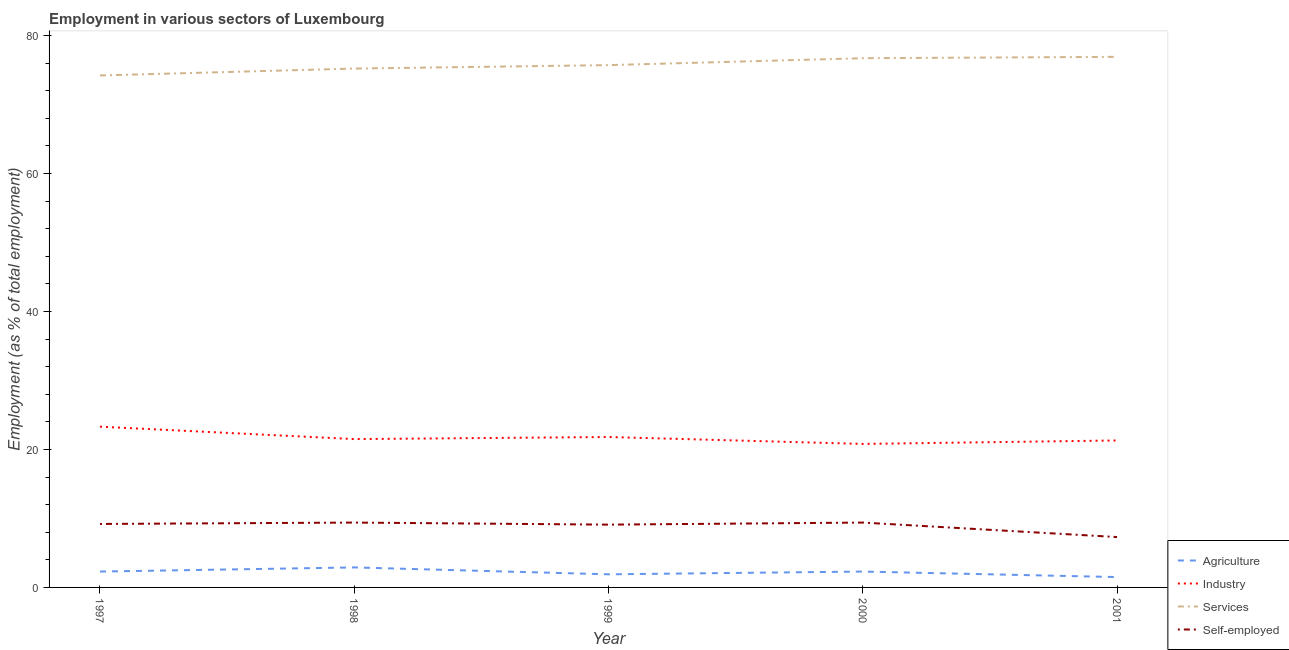What is the percentage of workers in agriculture in 1997?
Offer a terse response. 2.3. Across all years, what is the maximum percentage of workers in services?
Offer a very short reply. 76.9. Across all years, what is the minimum percentage of self employed workers?
Provide a short and direct response. 7.3. In which year was the percentage of workers in industry minimum?
Your answer should be compact. 2000. What is the total percentage of workers in industry in the graph?
Your answer should be compact. 108.7. What is the difference between the percentage of workers in agriculture in 1997 and that in 1998?
Offer a very short reply. -0.6. What is the difference between the percentage of self employed workers in 1997 and the percentage of workers in agriculture in 2000?
Make the answer very short. 6.9. What is the average percentage of workers in industry per year?
Make the answer very short. 21.74. In the year 1999, what is the difference between the percentage of workers in services and percentage of self employed workers?
Offer a very short reply. 66.6. In how many years, is the percentage of workers in industry greater than 56 %?
Provide a short and direct response. 0. What is the ratio of the percentage of workers in services in 1997 to that in 2000?
Your answer should be compact. 0.97. Is the percentage of workers in agriculture in 1999 less than that in 2000?
Give a very brief answer. Yes. What is the difference between the highest and the second highest percentage of workers in services?
Provide a succinct answer. 0.2. What is the difference between the highest and the lowest percentage of workers in services?
Offer a very short reply. 2.7. Is the percentage of workers in services strictly greater than the percentage of workers in industry over the years?
Offer a terse response. Yes. How many years are there in the graph?
Offer a very short reply. 5. What is the difference between two consecutive major ticks on the Y-axis?
Your response must be concise. 20. How are the legend labels stacked?
Keep it short and to the point. Vertical. What is the title of the graph?
Offer a very short reply. Employment in various sectors of Luxembourg. What is the label or title of the X-axis?
Make the answer very short. Year. What is the label or title of the Y-axis?
Offer a terse response. Employment (as % of total employment). What is the Employment (as % of total employment) in Agriculture in 1997?
Make the answer very short. 2.3. What is the Employment (as % of total employment) of Industry in 1997?
Your response must be concise. 23.3. What is the Employment (as % of total employment) in Services in 1997?
Offer a terse response. 74.2. What is the Employment (as % of total employment) of Self-employed in 1997?
Your response must be concise. 9.2. What is the Employment (as % of total employment) in Agriculture in 1998?
Ensure brevity in your answer.  2.9. What is the Employment (as % of total employment) in Services in 1998?
Give a very brief answer. 75.2. What is the Employment (as % of total employment) in Self-employed in 1998?
Your answer should be very brief. 9.4. What is the Employment (as % of total employment) in Agriculture in 1999?
Ensure brevity in your answer.  1.9. What is the Employment (as % of total employment) in Industry in 1999?
Offer a terse response. 21.8. What is the Employment (as % of total employment) of Services in 1999?
Provide a short and direct response. 75.7. What is the Employment (as % of total employment) of Self-employed in 1999?
Provide a succinct answer. 9.1. What is the Employment (as % of total employment) in Agriculture in 2000?
Your answer should be very brief. 2.3. What is the Employment (as % of total employment) in Industry in 2000?
Provide a succinct answer. 20.8. What is the Employment (as % of total employment) of Services in 2000?
Provide a succinct answer. 76.7. What is the Employment (as % of total employment) of Self-employed in 2000?
Ensure brevity in your answer.  9.4. What is the Employment (as % of total employment) of Industry in 2001?
Offer a very short reply. 21.3. What is the Employment (as % of total employment) in Services in 2001?
Offer a terse response. 76.9. What is the Employment (as % of total employment) of Self-employed in 2001?
Give a very brief answer. 7.3. Across all years, what is the maximum Employment (as % of total employment) in Agriculture?
Ensure brevity in your answer.  2.9. Across all years, what is the maximum Employment (as % of total employment) of Industry?
Provide a succinct answer. 23.3. Across all years, what is the maximum Employment (as % of total employment) in Services?
Provide a short and direct response. 76.9. Across all years, what is the maximum Employment (as % of total employment) of Self-employed?
Keep it short and to the point. 9.4. Across all years, what is the minimum Employment (as % of total employment) in Agriculture?
Offer a very short reply. 1.5. Across all years, what is the minimum Employment (as % of total employment) of Industry?
Your response must be concise. 20.8. Across all years, what is the minimum Employment (as % of total employment) in Services?
Your answer should be very brief. 74.2. Across all years, what is the minimum Employment (as % of total employment) in Self-employed?
Give a very brief answer. 7.3. What is the total Employment (as % of total employment) in Industry in the graph?
Your response must be concise. 108.7. What is the total Employment (as % of total employment) in Services in the graph?
Provide a succinct answer. 378.7. What is the total Employment (as % of total employment) in Self-employed in the graph?
Make the answer very short. 44.4. What is the difference between the Employment (as % of total employment) in Agriculture in 1997 and that in 1998?
Ensure brevity in your answer.  -0.6. What is the difference between the Employment (as % of total employment) of Industry in 1997 and that in 1998?
Your answer should be compact. 1.8. What is the difference between the Employment (as % of total employment) in Services in 1997 and that in 1998?
Offer a terse response. -1. What is the difference between the Employment (as % of total employment) of Industry in 1997 and that in 1999?
Your answer should be compact. 1.5. What is the difference between the Employment (as % of total employment) of Services in 1997 and that in 1999?
Offer a very short reply. -1.5. What is the difference between the Employment (as % of total employment) in Self-employed in 1997 and that in 1999?
Give a very brief answer. 0.1. What is the difference between the Employment (as % of total employment) of Services in 1997 and that in 2000?
Your answer should be very brief. -2.5. What is the difference between the Employment (as % of total employment) of Agriculture in 1997 and that in 2001?
Ensure brevity in your answer.  0.8. What is the difference between the Employment (as % of total employment) in Industry in 1997 and that in 2001?
Offer a terse response. 2. What is the difference between the Employment (as % of total employment) in Self-employed in 1997 and that in 2001?
Your answer should be compact. 1.9. What is the difference between the Employment (as % of total employment) in Services in 1998 and that in 1999?
Make the answer very short. -0.5. What is the difference between the Employment (as % of total employment) in Self-employed in 1998 and that in 1999?
Ensure brevity in your answer.  0.3. What is the difference between the Employment (as % of total employment) in Agriculture in 1998 and that in 2000?
Your answer should be very brief. 0.6. What is the difference between the Employment (as % of total employment) in Industry in 1998 and that in 2000?
Provide a short and direct response. 0.7. What is the difference between the Employment (as % of total employment) in Services in 1998 and that in 2000?
Offer a very short reply. -1.5. What is the difference between the Employment (as % of total employment) in Self-employed in 1998 and that in 2000?
Provide a short and direct response. 0. What is the difference between the Employment (as % of total employment) of Self-employed in 1998 and that in 2001?
Ensure brevity in your answer.  2.1. What is the difference between the Employment (as % of total employment) of Agriculture in 1999 and that in 2000?
Provide a succinct answer. -0.4. What is the difference between the Employment (as % of total employment) of Industry in 1999 and that in 2000?
Your answer should be compact. 1. What is the difference between the Employment (as % of total employment) of Services in 1999 and that in 2000?
Provide a succinct answer. -1. What is the difference between the Employment (as % of total employment) in Self-employed in 1999 and that in 2000?
Ensure brevity in your answer.  -0.3. What is the difference between the Employment (as % of total employment) of Industry in 1999 and that in 2001?
Offer a very short reply. 0.5. What is the difference between the Employment (as % of total employment) of Agriculture in 2000 and that in 2001?
Make the answer very short. 0.8. What is the difference between the Employment (as % of total employment) of Industry in 2000 and that in 2001?
Give a very brief answer. -0.5. What is the difference between the Employment (as % of total employment) in Self-employed in 2000 and that in 2001?
Keep it short and to the point. 2.1. What is the difference between the Employment (as % of total employment) of Agriculture in 1997 and the Employment (as % of total employment) of Industry in 1998?
Provide a short and direct response. -19.2. What is the difference between the Employment (as % of total employment) of Agriculture in 1997 and the Employment (as % of total employment) of Services in 1998?
Offer a terse response. -72.9. What is the difference between the Employment (as % of total employment) of Agriculture in 1997 and the Employment (as % of total employment) of Self-employed in 1998?
Provide a succinct answer. -7.1. What is the difference between the Employment (as % of total employment) of Industry in 1997 and the Employment (as % of total employment) of Services in 1998?
Keep it short and to the point. -51.9. What is the difference between the Employment (as % of total employment) in Services in 1997 and the Employment (as % of total employment) in Self-employed in 1998?
Offer a very short reply. 64.8. What is the difference between the Employment (as % of total employment) in Agriculture in 1997 and the Employment (as % of total employment) in Industry in 1999?
Provide a short and direct response. -19.5. What is the difference between the Employment (as % of total employment) of Agriculture in 1997 and the Employment (as % of total employment) of Services in 1999?
Your answer should be compact. -73.4. What is the difference between the Employment (as % of total employment) in Agriculture in 1997 and the Employment (as % of total employment) in Self-employed in 1999?
Your response must be concise. -6.8. What is the difference between the Employment (as % of total employment) in Industry in 1997 and the Employment (as % of total employment) in Services in 1999?
Offer a terse response. -52.4. What is the difference between the Employment (as % of total employment) in Industry in 1997 and the Employment (as % of total employment) in Self-employed in 1999?
Give a very brief answer. 14.2. What is the difference between the Employment (as % of total employment) in Services in 1997 and the Employment (as % of total employment) in Self-employed in 1999?
Your answer should be very brief. 65.1. What is the difference between the Employment (as % of total employment) of Agriculture in 1997 and the Employment (as % of total employment) of Industry in 2000?
Offer a very short reply. -18.5. What is the difference between the Employment (as % of total employment) of Agriculture in 1997 and the Employment (as % of total employment) of Services in 2000?
Give a very brief answer. -74.4. What is the difference between the Employment (as % of total employment) of Agriculture in 1997 and the Employment (as % of total employment) of Self-employed in 2000?
Give a very brief answer. -7.1. What is the difference between the Employment (as % of total employment) in Industry in 1997 and the Employment (as % of total employment) in Services in 2000?
Offer a very short reply. -53.4. What is the difference between the Employment (as % of total employment) of Services in 1997 and the Employment (as % of total employment) of Self-employed in 2000?
Your answer should be very brief. 64.8. What is the difference between the Employment (as % of total employment) in Agriculture in 1997 and the Employment (as % of total employment) in Industry in 2001?
Keep it short and to the point. -19. What is the difference between the Employment (as % of total employment) of Agriculture in 1997 and the Employment (as % of total employment) of Services in 2001?
Offer a terse response. -74.6. What is the difference between the Employment (as % of total employment) in Industry in 1997 and the Employment (as % of total employment) in Services in 2001?
Offer a terse response. -53.6. What is the difference between the Employment (as % of total employment) of Industry in 1997 and the Employment (as % of total employment) of Self-employed in 2001?
Provide a short and direct response. 16. What is the difference between the Employment (as % of total employment) of Services in 1997 and the Employment (as % of total employment) of Self-employed in 2001?
Keep it short and to the point. 66.9. What is the difference between the Employment (as % of total employment) in Agriculture in 1998 and the Employment (as % of total employment) in Industry in 1999?
Make the answer very short. -18.9. What is the difference between the Employment (as % of total employment) of Agriculture in 1998 and the Employment (as % of total employment) of Services in 1999?
Your response must be concise. -72.8. What is the difference between the Employment (as % of total employment) in Agriculture in 1998 and the Employment (as % of total employment) in Self-employed in 1999?
Offer a terse response. -6.2. What is the difference between the Employment (as % of total employment) in Industry in 1998 and the Employment (as % of total employment) in Services in 1999?
Keep it short and to the point. -54.2. What is the difference between the Employment (as % of total employment) in Industry in 1998 and the Employment (as % of total employment) in Self-employed in 1999?
Ensure brevity in your answer.  12.4. What is the difference between the Employment (as % of total employment) in Services in 1998 and the Employment (as % of total employment) in Self-employed in 1999?
Provide a short and direct response. 66.1. What is the difference between the Employment (as % of total employment) in Agriculture in 1998 and the Employment (as % of total employment) in Industry in 2000?
Provide a succinct answer. -17.9. What is the difference between the Employment (as % of total employment) in Agriculture in 1998 and the Employment (as % of total employment) in Services in 2000?
Give a very brief answer. -73.8. What is the difference between the Employment (as % of total employment) in Industry in 1998 and the Employment (as % of total employment) in Services in 2000?
Your answer should be very brief. -55.2. What is the difference between the Employment (as % of total employment) of Industry in 1998 and the Employment (as % of total employment) of Self-employed in 2000?
Offer a terse response. 12.1. What is the difference between the Employment (as % of total employment) of Services in 1998 and the Employment (as % of total employment) of Self-employed in 2000?
Your answer should be compact. 65.8. What is the difference between the Employment (as % of total employment) of Agriculture in 1998 and the Employment (as % of total employment) of Industry in 2001?
Ensure brevity in your answer.  -18.4. What is the difference between the Employment (as % of total employment) in Agriculture in 1998 and the Employment (as % of total employment) in Services in 2001?
Give a very brief answer. -74. What is the difference between the Employment (as % of total employment) in Industry in 1998 and the Employment (as % of total employment) in Services in 2001?
Offer a very short reply. -55.4. What is the difference between the Employment (as % of total employment) in Services in 1998 and the Employment (as % of total employment) in Self-employed in 2001?
Offer a very short reply. 67.9. What is the difference between the Employment (as % of total employment) in Agriculture in 1999 and the Employment (as % of total employment) in Industry in 2000?
Offer a terse response. -18.9. What is the difference between the Employment (as % of total employment) of Agriculture in 1999 and the Employment (as % of total employment) of Services in 2000?
Ensure brevity in your answer.  -74.8. What is the difference between the Employment (as % of total employment) in Agriculture in 1999 and the Employment (as % of total employment) in Self-employed in 2000?
Ensure brevity in your answer.  -7.5. What is the difference between the Employment (as % of total employment) in Industry in 1999 and the Employment (as % of total employment) in Services in 2000?
Your answer should be compact. -54.9. What is the difference between the Employment (as % of total employment) of Services in 1999 and the Employment (as % of total employment) of Self-employed in 2000?
Ensure brevity in your answer.  66.3. What is the difference between the Employment (as % of total employment) in Agriculture in 1999 and the Employment (as % of total employment) in Industry in 2001?
Ensure brevity in your answer.  -19.4. What is the difference between the Employment (as % of total employment) of Agriculture in 1999 and the Employment (as % of total employment) of Services in 2001?
Provide a short and direct response. -75. What is the difference between the Employment (as % of total employment) of Agriculture in 1999 and the Employment (as % of total employment) of Self-employed in 2001?
Keep it short and to the point. -5.4. What is the difference between the Employment (as % of total employment) of Industry in 1999 and the Employment (as % of total employment) of Services in 2001?
Provide a succinct answer. -55.1. What is the difference between the Employment (as % of total employment) of Industry in 1999 and the Employment (as % of total employment) of Self-employed in 2001?
Offer a very short reply. 14.5. What is the difference between the Employment (as % of total employment) of Services in 1999 and the Employment (as % of total employment) of Self-employed in 2001?
Provide a short and direct response. 68.4. What is the difference between the Employment (as % of total employment) in Agriculture in 2000 and the Employment (as % of total employment) in Services in 2001?
Your answer should be very brief. -74.6. What is the difference between the Employment (as % of total employment) of Agriculture in 2000 and the Employment (as % of total employment) of Self-employed in 2001?
Provide a short and direct response. -5. What is the difference between the Employment (as % of total employment) in Industry in 2000 and the Employment (as % of total employment) in Services in 2001?
Offer a terse response. -56.1. What is the difference between the Employment (as % of total employment) of Services in 2000 and the Employment (as % of total employment) of Self-employed in 2001?
Keep it short and to the point. 69.4. What is the average Employment (as % of total employment) of Agriculture per year?
Give a very brief answer. 2.18. What is the average Employment (as % of total employment) of Industry per year?
Ensure brevity in your answer.  21.74. What is the average Employment (as % of total employment) of Services per year?
Offer a terse response. 75.74. What is the average Employment (as % of total employment) in Self-employed per year?
Your answer should be very brief. 8.88. In the year 1997, what is the difference between the Employment (as % of total employment) of Agriculture and Employment (as % of total employment) of Industry?
Your answer should be compact. -21. In the year 1997, what is the difference between the Employment (as % of total employment) of Agriculture and Employment (as % of total employment) of Services?
Offer a very short reply. -71.9. In the year 1997, what is the difference between the Employment (as % of total employment) in Industry and Employment (as % of total employment) in Services?
Your response must be concise. -50.9. In the year 1997, what is the difference between the Employment (as % of total employment) in Industry and Employment (as % of total employment) in Self-employed?
Offer a terse response. 14.1. In the year 1997, what is the difference between the Employment (as % of total employment) of Services and Employment (as % of total employment) of Self-employed?
Give a very brief answer. 65. In the year 1998, what is the difference between the Employment (as % of total employment) of Agriculture and Employment (as % of total employment) of Industry?
Your response must be concise. -18.6. In the year 1998, what is the difference between the Employment (as % of total employment) of Agriculture and Employment (as % of total employment) of Services?
Your answer should be very brief. -72.3. In the year 1998, what is the difference between the Employment (as % of total employment) in Industry and Employment (as % of total employment) in Services?
Your answer should be compact. -53.7. In the year 1998, what is the difference between the Employment (as % of total employment) in Industry and Employment (as % of total employment) in Self-employed?
Your answer should be compact. 12.1. In the year 1998, what is the difference between the Employment (as % of total employment) of Services and Employment (as % of total employment) of Self-employed?
Offer a very short reply. 65.8. In the year 1999, what is the difference between the Employment (as % of total employment) of Agriculture and Employment (as % of total employment) of Industry?
Keep it short and to the point. -19.9. In the year 1999, what is the difference between the Employment (as % of total employment) in Agriculture and Employment (as % of total employment) in Services?
Make the answer very short. -73.8. In the year 1999, what is the difference between the Employment (as % of total employment) of Industry and Employment (as % of total employment) of Services?
Your answer should be compact. -53.9. In the year 1999, what is the difference between the Employment (as % of total employment) in Industry and Employment (as % of total employment) in Self-employed?
Offer a very short reply. 12.7. In the year 1999, what is the difference between the Employment (as % of total employment) in Services and Employment (as % of total employment) in Self-employed?
Provide a short and direct response. 66.6. In the year 2000, what is the difference between the Employment (as % of total employment) of Agriculture and Employment (as % of total employment) of Industry?
Give a very brief answer. -18.5. In the year 2000, what is the difference between the Employment (as % of total employment) of Agriculture and Employment (as % of total employment) of Services?
Your answer should be compact. -74.4. In the year 2000, what is the difference between the Employment (as % of total employment) of Industry and Employment (as % of total employment) of Services?
Ensure brevity in your answer.  -55.9. In the year 2000, what is the difference between the Employment (as % of total employment) of Industry and Employment (as % of total employment) of Self-employed?
Give a very brief answer. 11.4. In the year 2000, what is the difference between the Employment (as % of total employment) in Services and Employment (as % of total employment) in Self-employed?
Your answer should be very brief. 67.3. In the year 2001, what is the difference between the Employment (as % of total employment) in Agriculture and Employment (as % of total employment) in Industry?
Your response must be concise. -19.8. In the year 2001, what is the difference between the Employment (as % of total employment) of Agriculture and Employment (as % of total employment) of Services?
Ensure brevity in your answer.  -75.4. In the year 2001, what is the difference between the Employment (as % of total employment) in Industry and Employment (as % of total employment) in Services?
Offer a very short reply. -55.6. In the year 2001, what is the difference between the Employment (as % of total employment) of Industry and Employment (as % of total employment) of Self-employed?
Offer a terse response. 14. In the year 2001, what is the difference between the Employment (as % of total employment) in Services and Employment (as % of total employment) in Self-employed?
Keep it short and to the point. 69.6. What is the ratio of the Employment (as % of total employment) in Agriculture in 1997 to that in 1998?
Provide a short and direct response. 0.79. What is the ratio of the Employment (as % of total employment) of Industry in 1997 to that in 1998?
Make the answer very short. 1.08. What is the ratio of the Employment (as % of total employment) in Services in 1997 to that in 1998?
Give a very brief answer. 0.99. What is the ratio of the Employment (as % of total employment) in Self-employed in 1997 to that in 1998?
Keep it short and to the point. 0.98. What is the ratio of the Employment (as % of total employment) in Agriculture in 1997 to that in 1999?
Provide a succinct answer. 1.21. What is the ratio of the Employment (as % of total employment) in Industry in 1997 to that in 1999?
Offer a terse response. 1.07. What is the ratio of the Employment (as % of total employment) of Services in 1997 to that in 1999?
Give a very brief answer. 0.98. What is the ratio of the Employment (as % of total employment) in Self-employed in 1997 to that in 1999?
Your answer should be compact. 1.01. What is the ratio of the Employment (as % of total employment) of Industry in 1997 to that in 2000?
Your response must be concise. 1.12. What is the ratio of the Employment (as % of total employment) in Services in 1997 to that in 2000?
Offer a terse response. 0.97. What is the ratio of the Employment (as % of total employment) in Self-employed in 1997 to that in 2000?
Provide a succinct answer. 0.98. What is the ratio of the Employment (as % of total employment) in Agriculture in 1997 to that in 2001?
Keep it short and to the point. 1.53. What is the ratio of the Employment (as % of total employment) in Industry in 1997 to that in 2001?
Keep it short and to the point. 1.09. What is the ratio of the Employment (as % of total employment) in Services in 1997 to that in 2001?
Ensure brevity in your answer.  0.96. What is the ratio of the Employment (as % of total employment) of Self-employed in 1997 to that in 2001?
Ensure brevity in your answer.  1.26. What is the ratio of the Employment (as % of total employment) in Agriculture in 1998 to that in 1999?
Give a very brief answer. 1.53. What is the ratio of the Employment (as % of total employment) in Industry in 1998 to that in 1999?
Your answer should be very brief. 0.99. What is the ratio of the Employment (as % of total employment) in Services in 1998 to that in 1999?
Your response must be concise. 0.99. What is the ratio of the Employment (as % of total employment) in Self-employed in 1998 to that in 1999?
Your response must be concise. 1.03. What is the ratio of the Employment (as % of total employment) in Agriculture in 1998 to that in 2000?
Make the answer very short. 1.26. What is the ratio of the Employment (as % of total employment) in Industry in 1998 to that in 2000?
Give a very brief answer. 1.03. What is the ratio of the Employment (as % of total employment) in Services in 1998 to that in 2000?
Give a very brief answer. 0.98. What is the ratio of the Employment (as % of total employment) of Agriculture in 1998 to that in 2001?
Your response must be concise. 1.93. What is the ratio of the Employment (as % of total employment) in Industry in 1998 to that in 2001?
Make the answer very short. 1.01. What is the ratio of the Employment (as % of total employment) in Services in 1998 to that in 2001?
Provide a short and direct response. 0.98. What is the ratio of the Employment (as % of total employment) of Self-employed in 1998 to that in 2001?
Your answer should be very brief. 1.29. What is the ratio of the Employment (as % of total employment) of Agriculture in 1999 to that in 2000?
Your answer should be compact. 0.83. What is the ratio of the Employment (as % of total employment) of Industry in 1999 to that in 2000?
Provide a short and direct response. 1.05. What is the ratio of the Employment (as % of total employment) of Self-employed in 1999 to that in 2000?
Keep it short and to the point. 0.97. What is the ratio of the Employment (as % of total employment) of Agriculture in 1999 to that in 2001?
Ensure brevity in your answer.  1.27. What is the ratio of the Employment (as % of total employment) of Industry in 1999 to that in 2001?
Offer a very short reply. 1.02. What is the ratio of the Employment (as % of total employment) of Services in 1999 to that in 2001?
Your answer should be very brief. 0.98. What is the ratio of the Employment (as % of total employment) of Self-employed in 1999 to that in 2001?
Your response must be concise. 1.25. What is the ratio of the Employment (as % of total employment) in Agriculture in 2000 to that in 2001?
Give a very brief answer. 1.53. What is the ratio of the Employment (as % of total employment) of Industry in 2000 to that in 2001?
Provide a succinct answer. 0.98. What is the ratio of the Employment (as % of total employment) in Services in 2000 to that in 2001?
Ensure brevity in your answer.  1. What is the ratio of the Employment (as % of total employment) of Self-employed in 2000 to that in 2001?
Your response must be concise. 1.29. What is the difference between the highest and the second highest Employment (as % of total employment) in Self-employed?
Keep it short and to the point. 0. What is the difference between the highest and the lowest Employment (as % of total employment) in Agriculture?
Give a very brief answer. 1.4. What is the difference between the highest and the lowest Employment (as % of total employment) of Industry?
Make the answer very short. 2.5. 